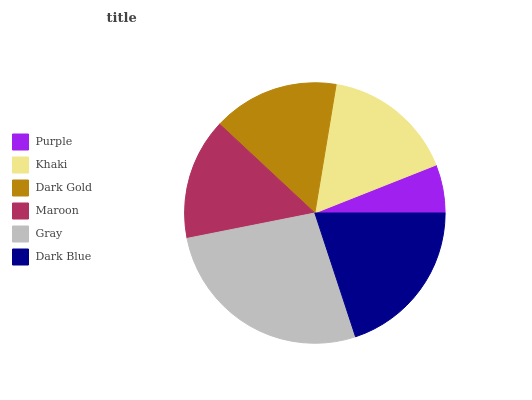Is Purple the minimum?
Answer yes or no. Yes. Is Gray the maximum?
Answer yes or no. Yes. Is Khaki the minimum?
Answer yes or no. No. Is Khaki the maximum?
Answer yes or no. No. Is Khaki greater than Purple?
Answer yes or no. Yes. Is Purple less than Khaki?
Answer yes or no. Yes. Is Purple greater than Khaki?
Answer yes or no. No. Is Khaki less than Purple?
Answer yes or no. No. Is Khaki the high median?
Answer yes or no. Yes. Is Dark Gold the low median?
Answer yes or no. Yes. Is Maroon the high median?
Answer yes or no. No. Is Dark Blue the low median?
Answer yes or no. No. 